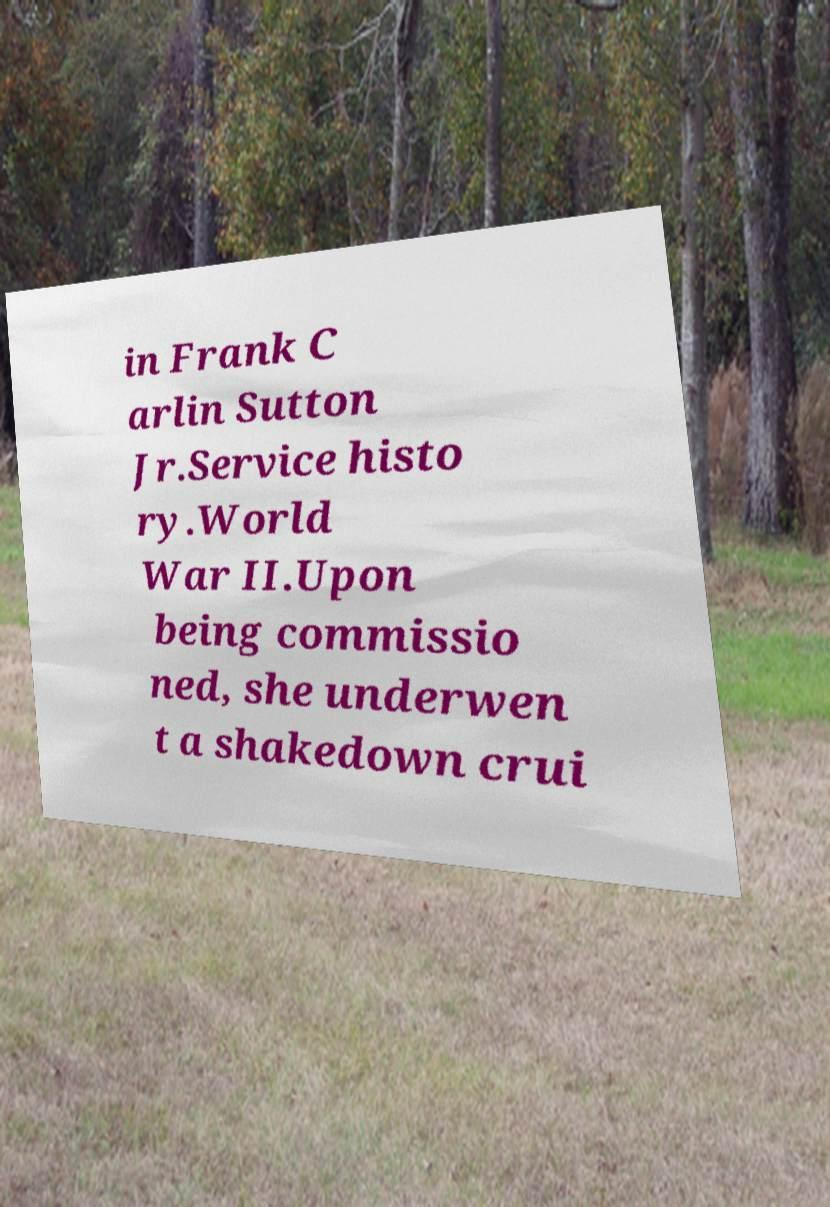Could you assist in decoding the text presented in this image and type it out clearly? in Frank C arlin Sutton Jr.Service histo ry.World War II.Upon being commissio ned, she underwen t a shakedown crui 